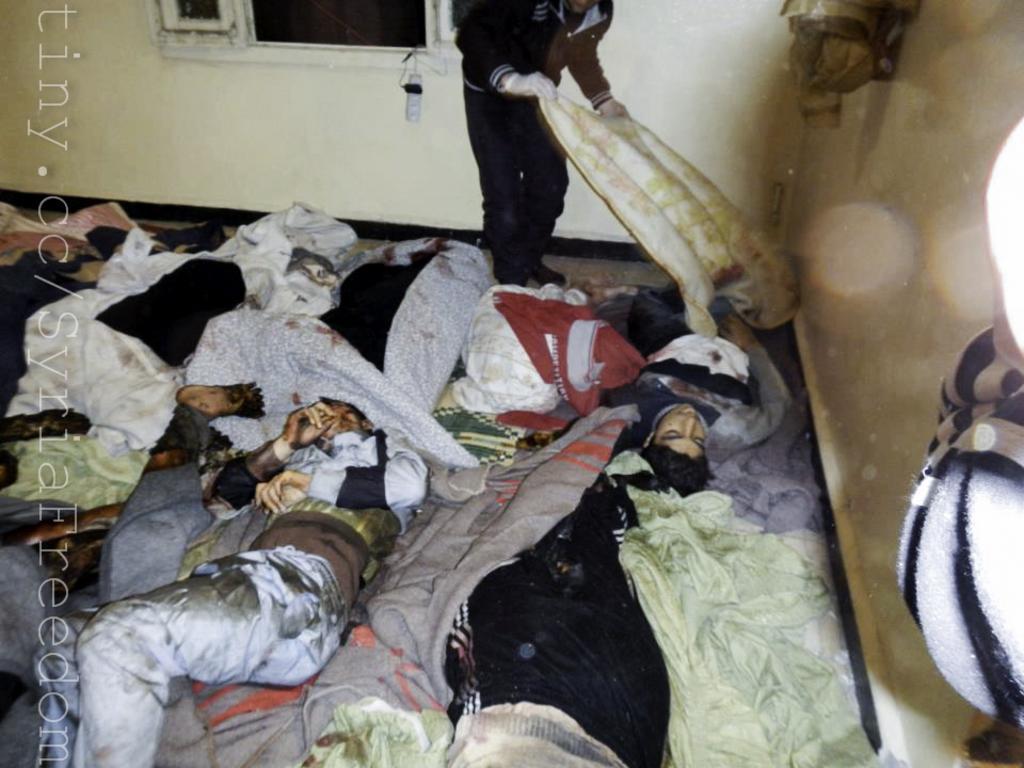Describe this image in one or two sentences. On the right side some text is like tiny. cc/syria Freedom. In the middle we can see some fellows were injured and one person was standing and holding something. On the left side we can see a wall which is blurred. 